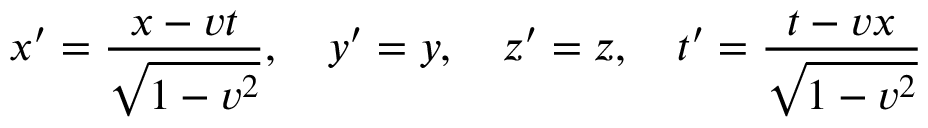<formula> <loc_0><loc_0><loc_500><loc_500>x ^ { \prime } = { \frac { x - v t } { \sqrt { 1 - v ^ { 2 } } } } , \quad y ^ { \prime } = y , \quad z ^ { \prime } = z , \quad t ^ { \prime } = { \frac { t - v x } { \sqrt { 1 - v ^ { 2 } } } }</formula> 